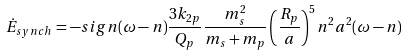Convert formula to latex. <formula><loc_0><loc_0><loc_500><loc_500>\dot { E } _ { s y n c h } = - s i g n ( \omega - n ) \frac { 3 k _ { 2 p } } { Q _ { p } } \frac { m _ { s } ^ { 2 } } { m _ { s } + m _ { p } } \left ( \frac { R _ { p } } { a } \right ) ^ { 5 } n ^ { 2 } a ^ { 2 } ( \omega - n )</formula> 